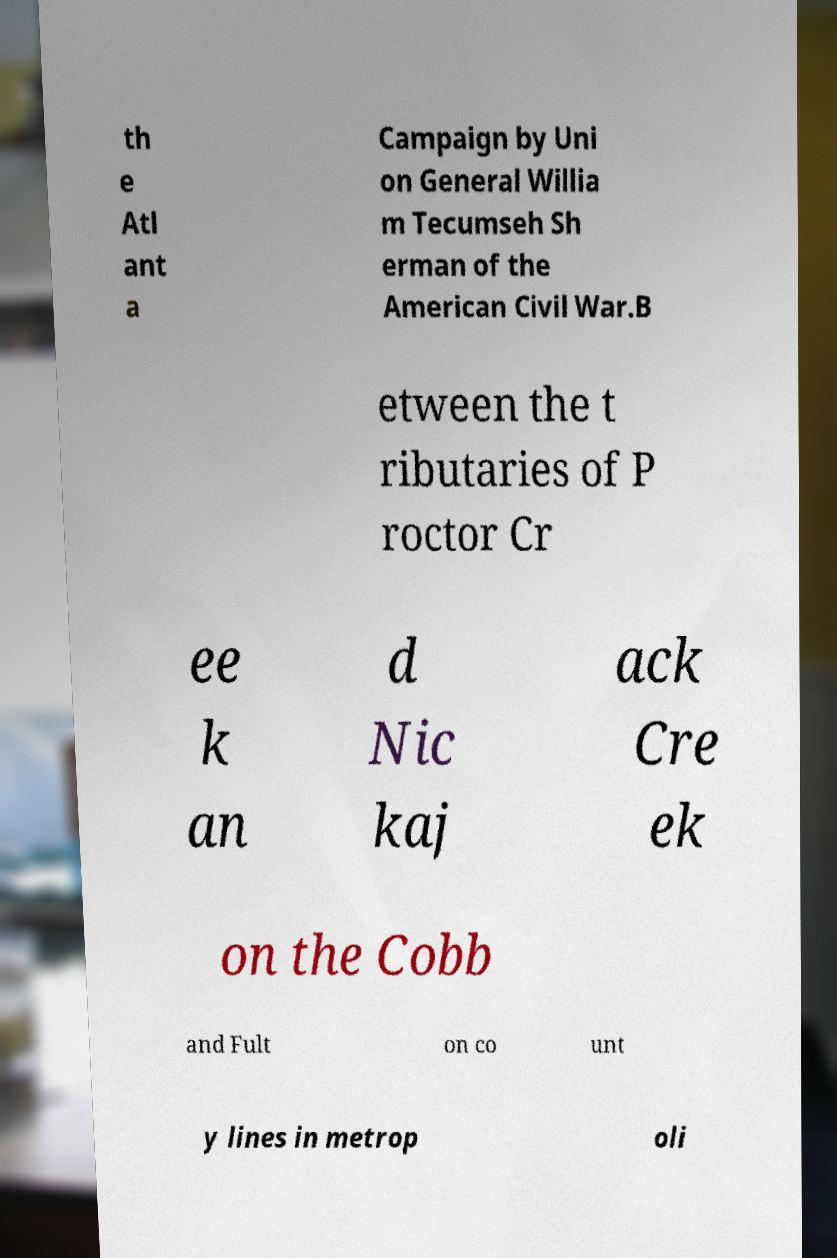Could you assist in decoding the text presented in this image and type it out clearly? th e Atl ant a Campaign by Uni on General Willia m Tecumseh Sh erman of the American Civil War.B etween the t ributaries of P roctor Cr ee k an d Nic kaj ack Cre ek on the Cobb and Fult on co unt y lines in metrop oli 